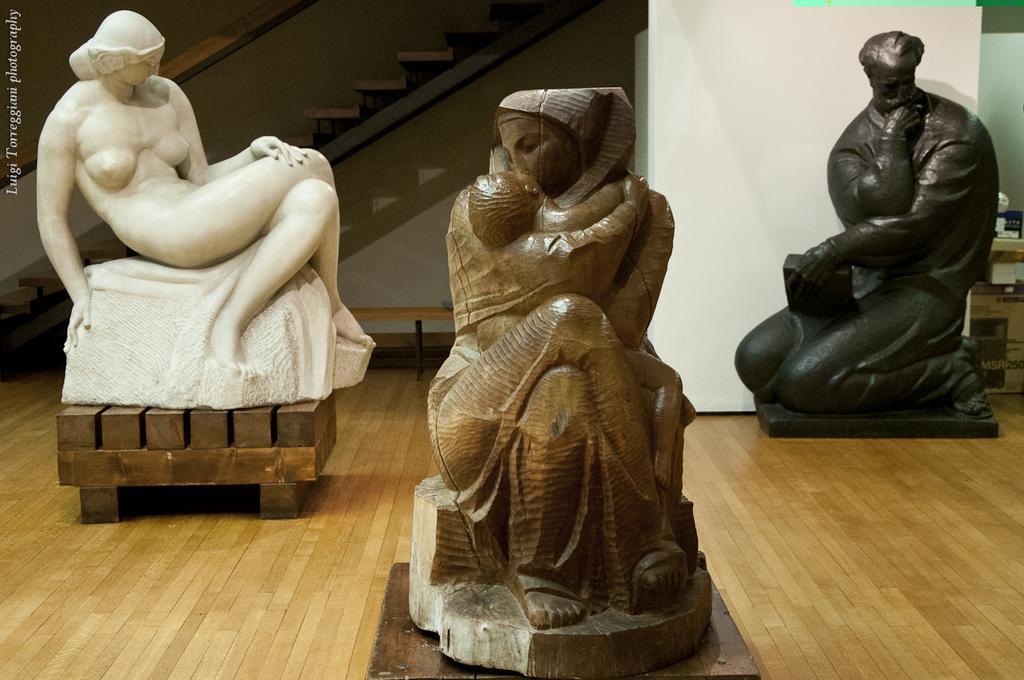Could you give a brief overview of what you see in this image? In this picture there are sculptures. At the back there is a staircase. On the right side of the image there are objects and there is a cardboard box. At the back there is a bench. At the bottom there is a wooden floor. At the top left there is a text. 